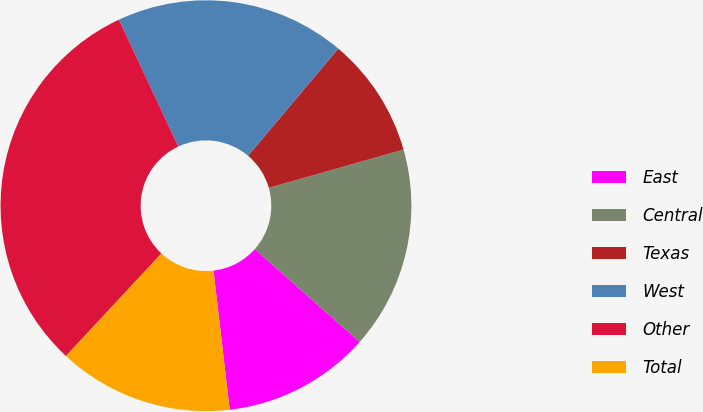Convert chart to OTSL. <chart><loc_0><loc_0><loc_500><loc_500><pie_chart><fcel>East<fcel>Central<fcel>Texas<fcel>West<fcel>Other<fcel>Total<nl><fcel>11.62%<fcel>15.95%<fcel>9.45%<fcel>18.11%<fcel>31.1%<fcel>13.78%<nl></chart> 